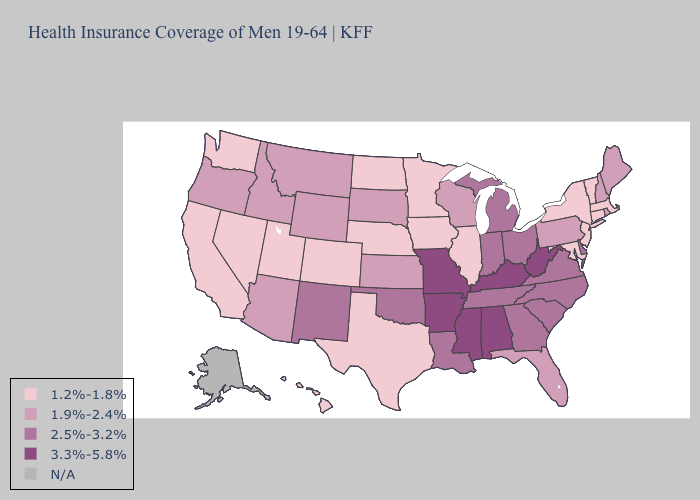What is the lowest value in states that border Wyoming?
Concise answer only. 1.2%-1.8%. Does Missouri have the highest value in the MidWest?
Be succinct. Yes. Name the states that have a value in the range 1.2%-1.8%?
Concise answer only. California, Colorado, Connecticut, Hawaii, Illinois, Iowa, Maryland, Massachusetts, Minnesota, Nebraska, Nevada, New Jersey, New York, North Dakota, Texas, Utah, Vermont, Washington. What is the highest value in states that border Massachusetts?
Keep it brief. 1.9%-2.4%. Name the states that have a value in the range 1.2%-1.8%?
Concise answer only. California, Colorado, Connecticut, Hawaii, Illinois, Iowa, Maryland, Massachusetts, Minnesota, Nebraska, Nevada, New Jersey, New York, North Dakota, Texas, Utah, Vermont, Washington. Does the first symbol in the legend represent the smallest category?
Keep it brief. Yes. What is the highest value in states that border Connecticut?
Quick response, please. 1.9%-2.4%. Name the states that have a value in the range 2.5%-3.2%?
Concise answer only. Delaware, Georgia, Indiana, Louisiana, Michigan, New Mexico, North Carolina, Ohio, Oklahoma, South Carolina, Tennessee, Virginia. What is the value of Virginia?
Quick response, please. 2.5%-3.2%. What is the value of Tennessee?
Write a very short answer. 2.5%-3.2%. What is the value of Massachusetts?
Be succinct. 1.2%-1.8%. What is the highest value in states that border South Carolina?
Concise answer only. 2.5%-3.2%. 